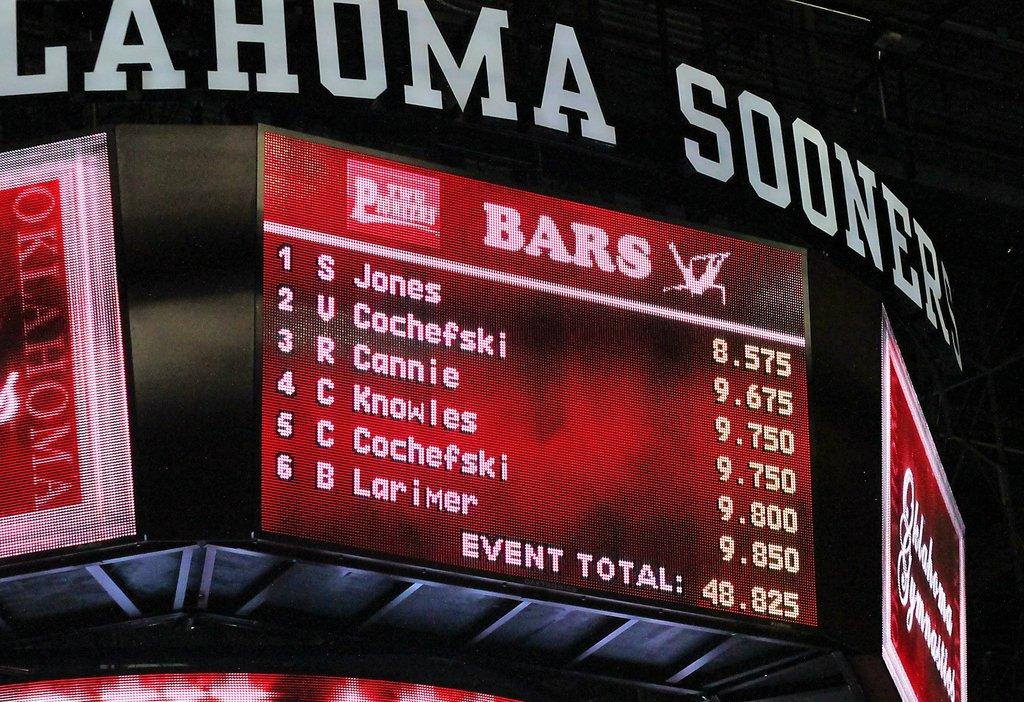<image>
Summarize the visual content of the image. A score sheet on the Jumbo tron for the Ohlahoma Sooners. 